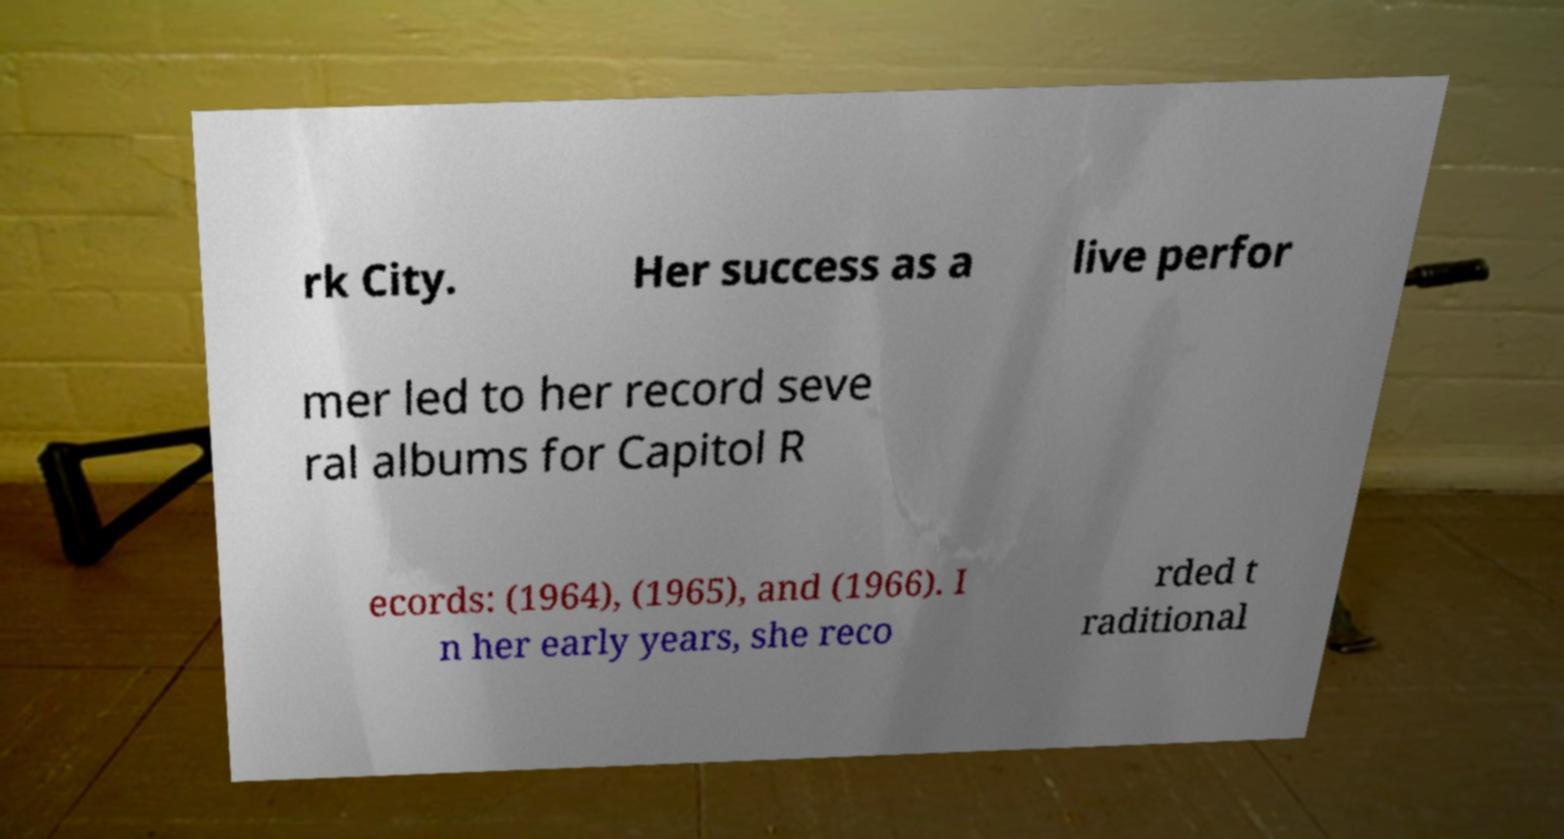There's text embedded in this image that I need extracted. Can you transcribe it verbatim? rk City. Her success as a live perfor mer led to her record seve ral albums for Capitol R ecords: (1964), (1965), and (1966). I n her early years, she reco rded t raditional 